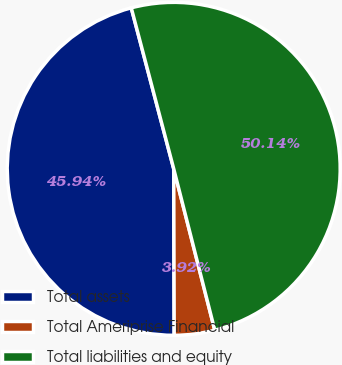Convert chart to OTSL. <chart><loc_0><loc_0><loc_500><loc_500><pie_chart><fcel>Total assets<fcel>Total Ameriprise Financial<fcel>Total liabilities and equity<nl><fcel>45.94%<fcel>3.92%<fcel>50.14%<nl></chart> 